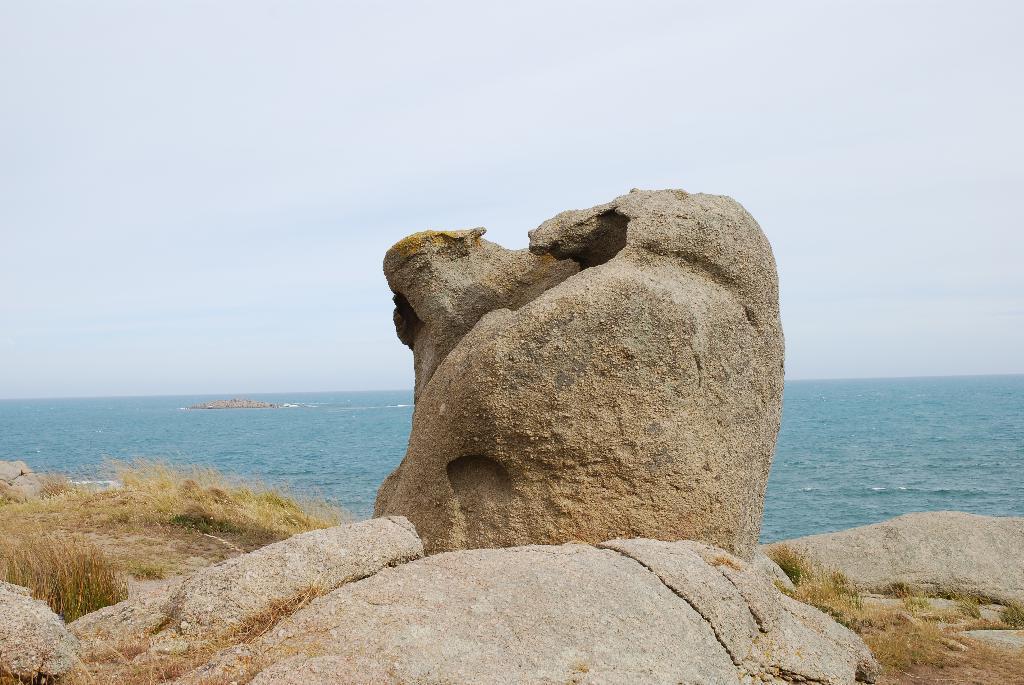In one or two sentences, can you explain what this image depicts? This is an outside view. At the bottom there are some rocks and grass. In the background there is an Ocean. At the top of the image I can see the sky. 